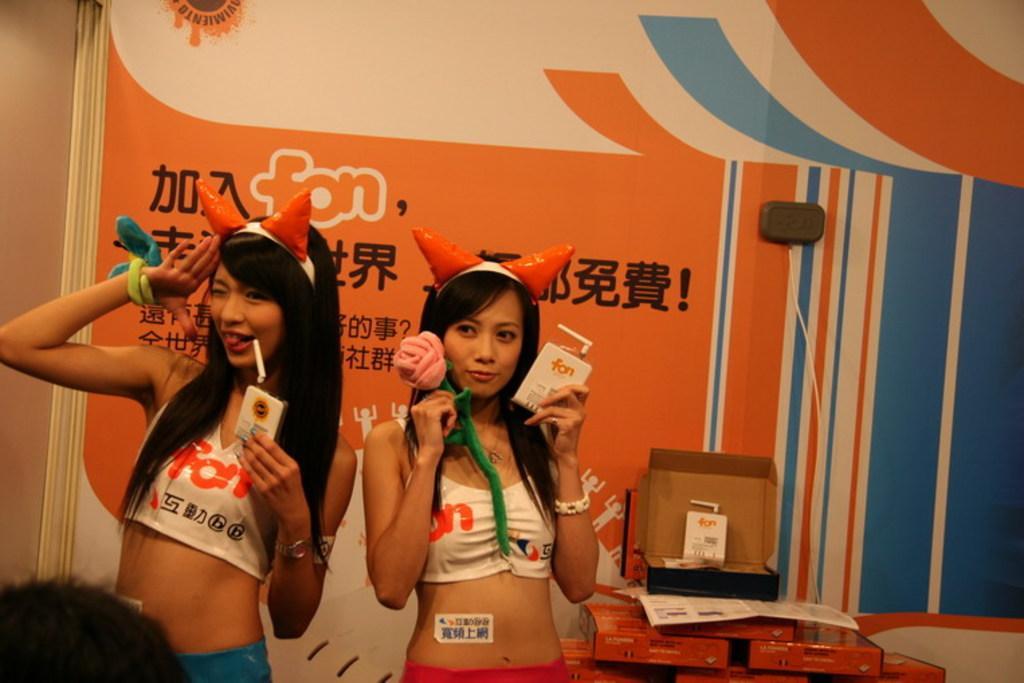In one or two sentences, can you explain what this image depicts? In this picture there are two girls on the left side of the image and there are boxes on the right side of the image, there is a poster in the background area of the image. 